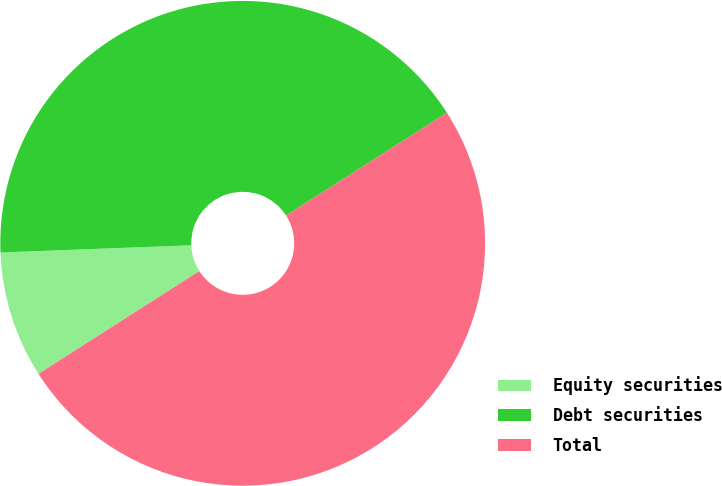<chart> <loc_0><loc_0><loc_500><loc_500><pie_chart><fcel>Equity securities<fcel>Debt securities<fcel>Total<nl><fcel>8.45%<fcel>41.55%<fcel>50.0%<nl></chart> 